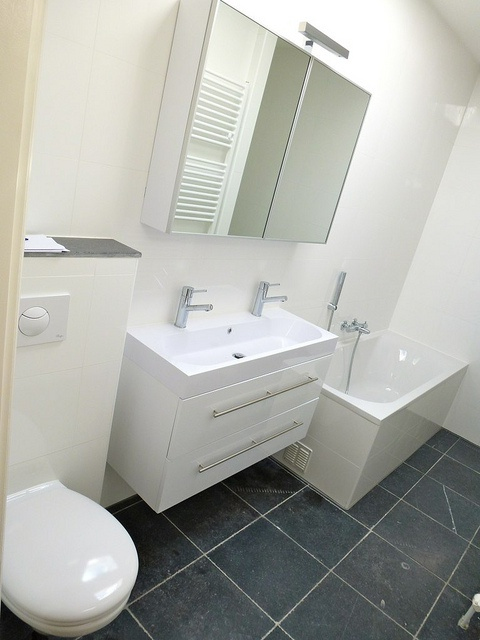Describe the objects in this image and their specific colors. I can see toilet in tan, lightgray, darkgray, and gray tones and sink in tan, lightgray, and darkgray tones in this image. 